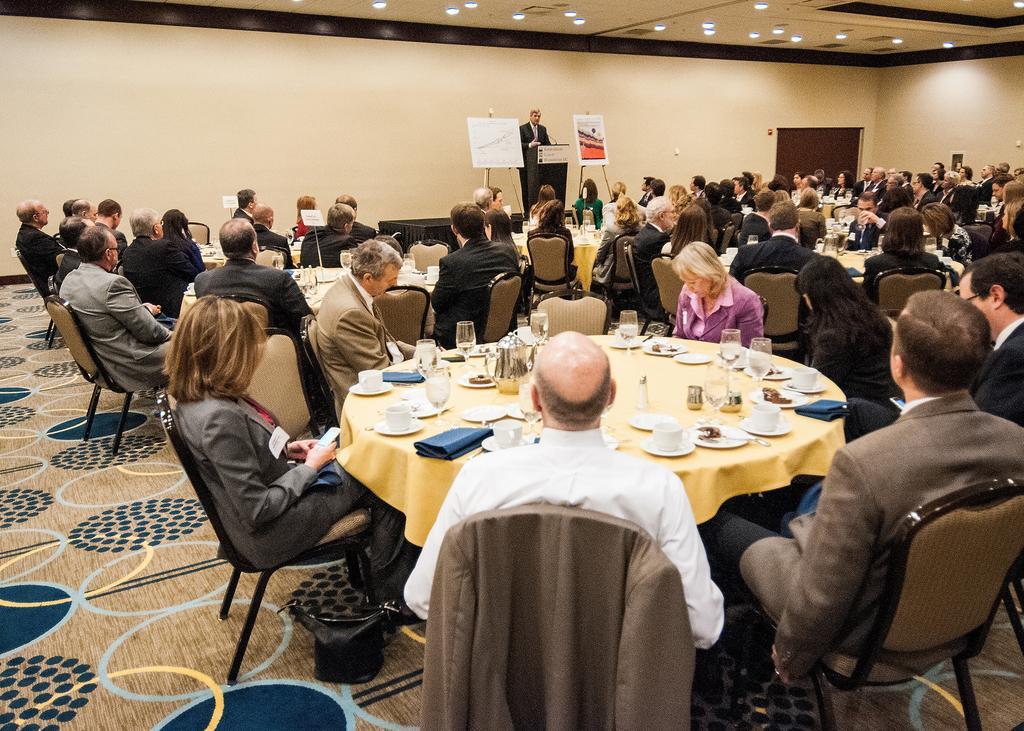Could you give a brief overview of what you see in this image? Persons are sitting on a chair. In-front of this person there is table, on a table there are cups and glasses. Far this person is standing. In-front of this person there is a podium. Beside this podium there are posters. On top there are lights. 